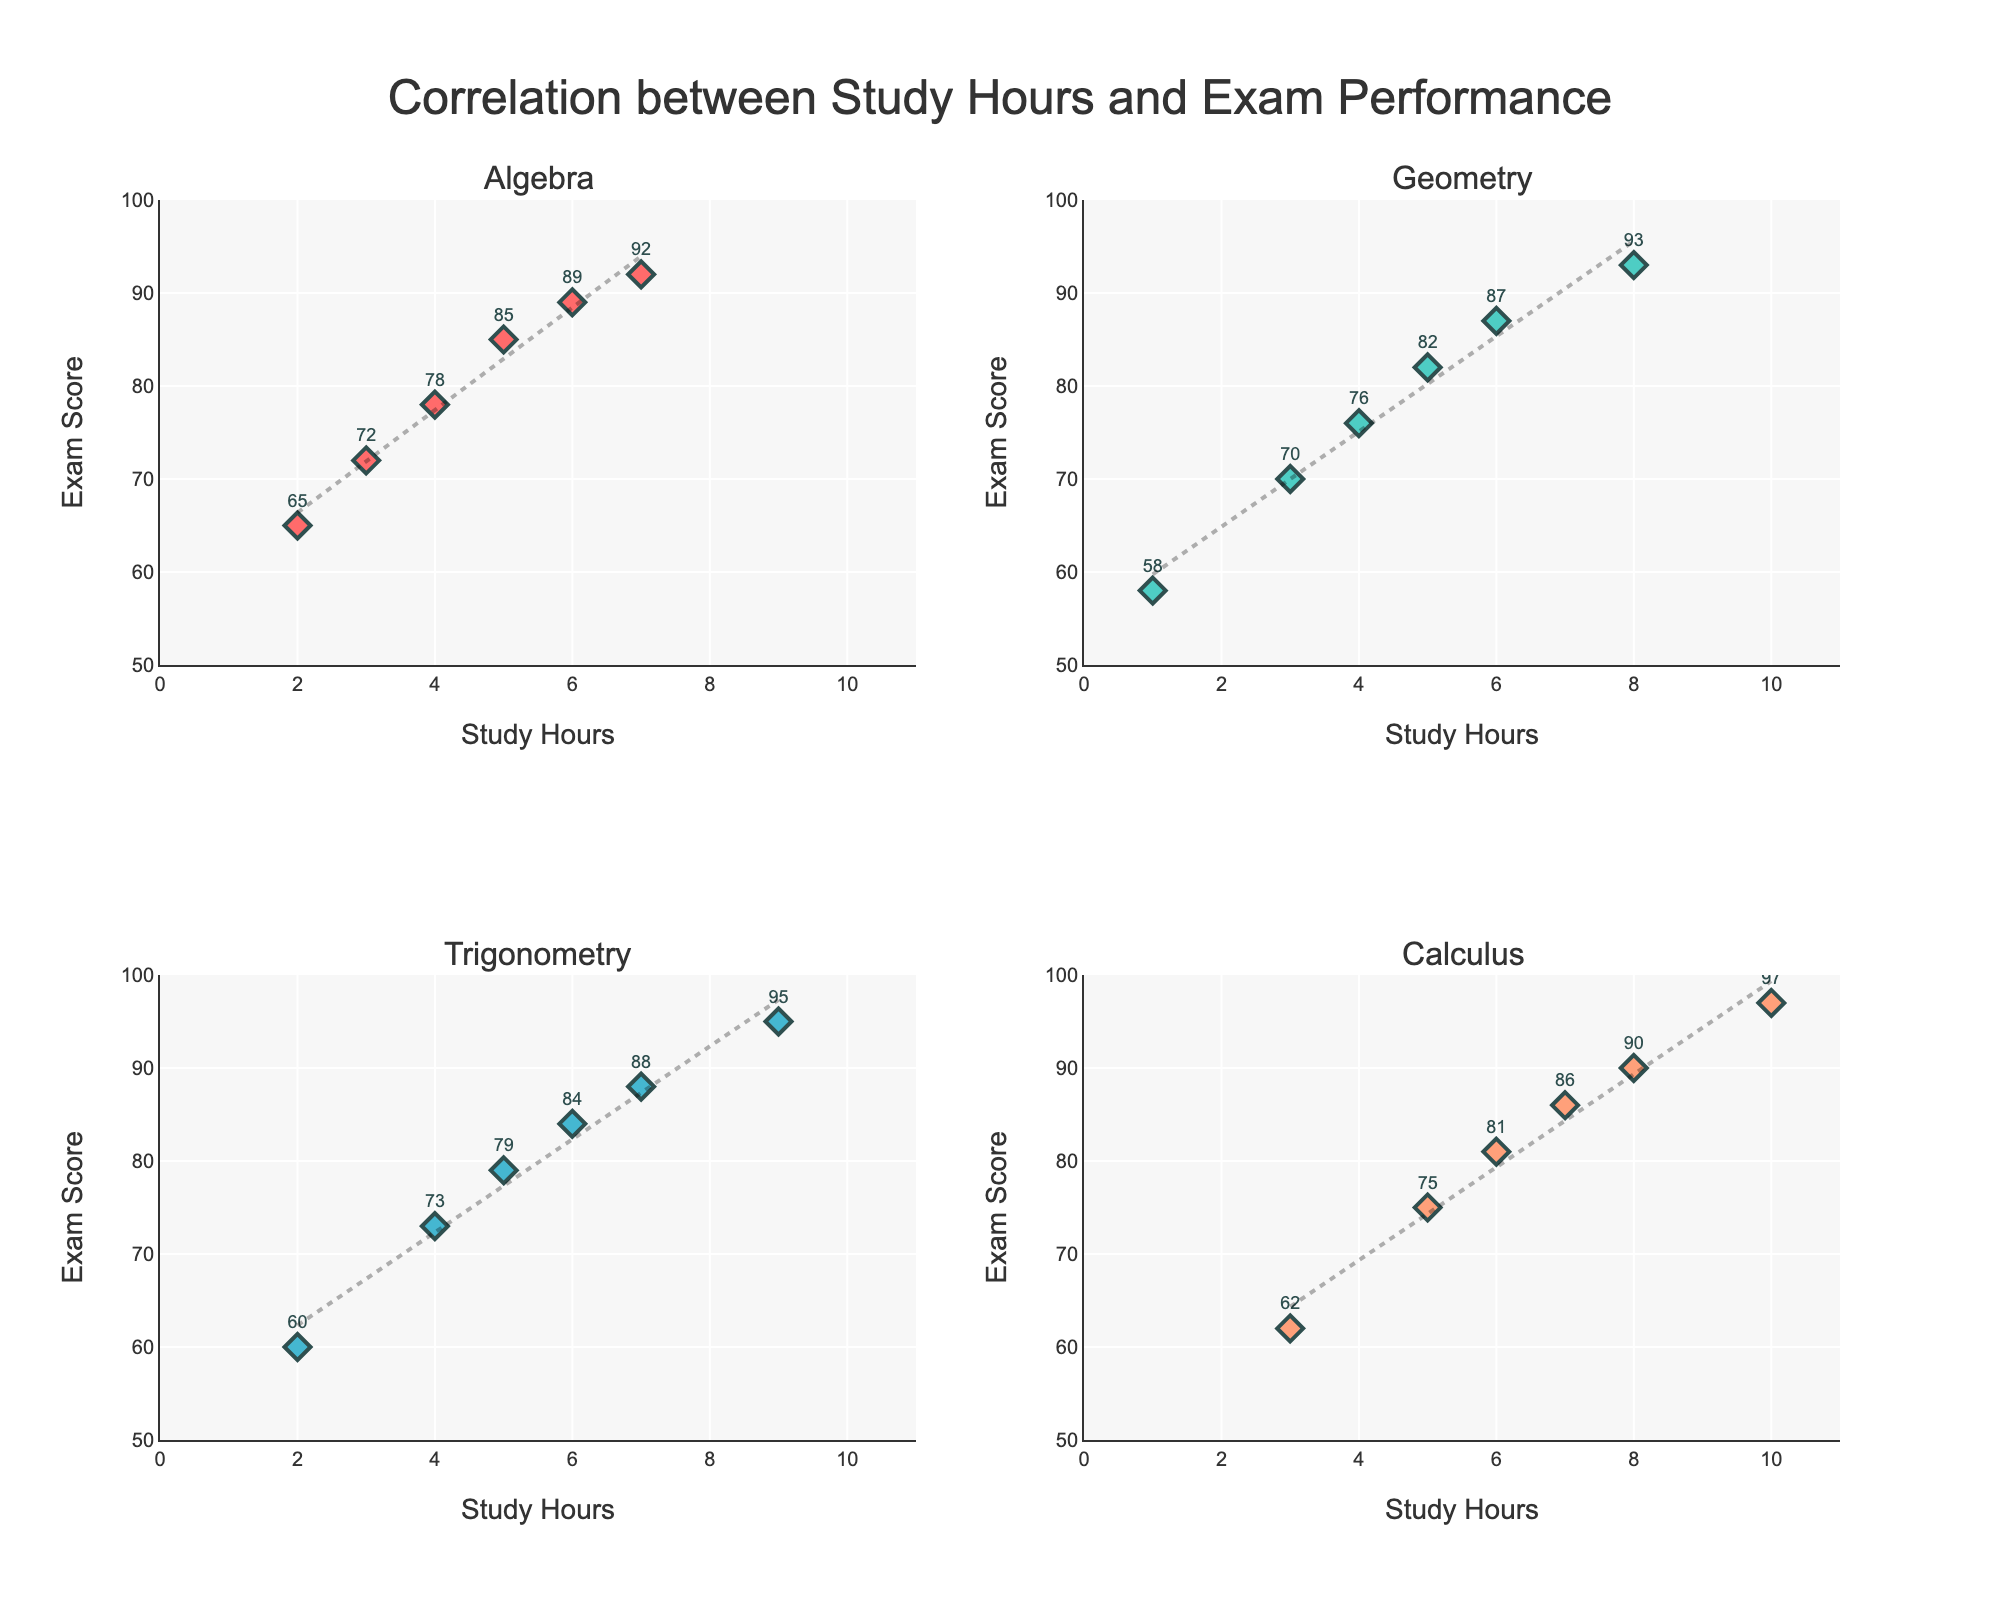How many topics are displayed in the subplots? The figure shows four subplots, each representing one of the math topics listed in the data: Algebra, Geometry, Trigonometry, and Calculus.
Answer: Four How does the Exam Score generally change with increasing Study Hours for Geometry? For Geometry, as Study Hours increase, Exam Scores also generally increase, suggesting a positive correlation between the two variables.
Answer: Positive correlation What is the trendline equation for Algebra? The trendline equation for Algebra can be inferred by visually estimating the slope and y-intercept from the scatter plot trendline. From the plot, the relationship seems roughly linear with the equation of the form y ≈ m * x + c where m (slope) and c (intercept) need to be approximated.
Answer: y ≈ 4.5 * x + 60 Which math topic shows the highest Exam Score for a given Study Hours? To determine this, look at the scatter points across all subplots for the same Study Hours. For example, for Study Hours at 5, Calculus shows the highest Exam Score compared to Algebra, Geometry, and Trigonometry.
Answer: Calculus Compare the slopes of the trendlines for Trigonometry and Calculus. Which one is steeper? By visually examining the trendlines in the subplots for Trigonometry and Calculus, it appears that the slope of the trendline for Calculus is slightly steeper than that for Trigonometry. This indicates a stronger increase in Exam Score with additional Study Hours for Calculus.
Answer: Calculus Estimate the Exam Score for Geometry if a student studies for 7 hours. For Geometry, although there is no data point at 7 Study Hours, the trendline in the scatter plot can help estimate the Exam Score. The trendline suggests an approximate Exam Score of around 90 when interpolated.
Answer: ~90 Which topic has the most scattered data points around the trendline, indicating less predictability? To identify the topic with the most scattered data points around the trendline, look at the spread of data points relative to the trendline in each subplot. Geometry and Algebra show points closer to the trendline, whereas Trigonometry and Calculus have some deviation, but Geometry is slightly more scattered.
Answer: Geometry 